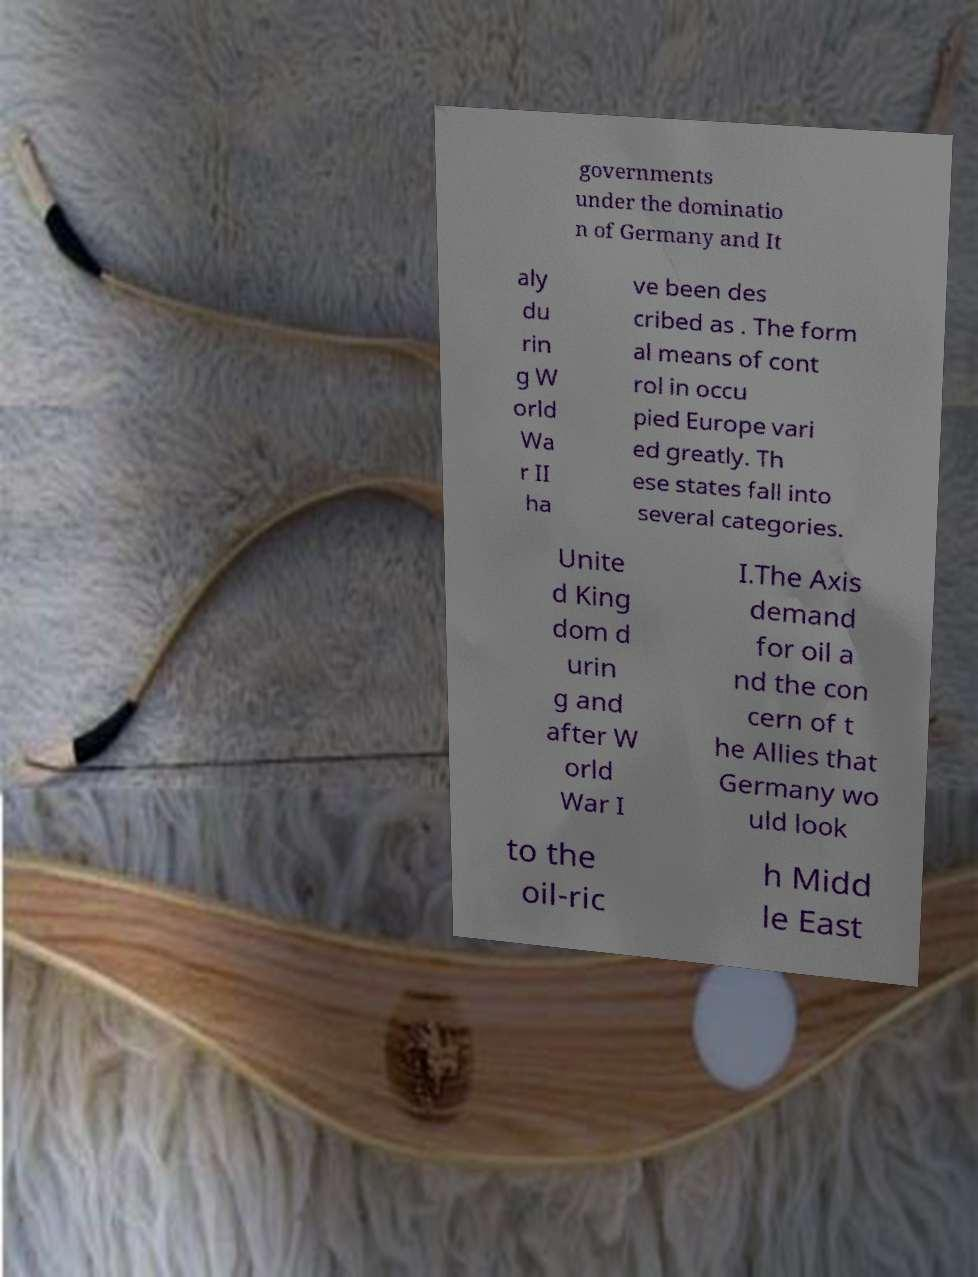Please read and relay the text visible in this image. What does it say? governments under the dominatio n of Germany and It aly du rin g W orld Wa r II ha ve been des cribed as . The form al means of cont rol in occu pied Europe vari ed greatly. Th ese states fall into several categories. Unite d King dom d urin g and after W orld War I I.The Axis demand for oil a nd the con cern of t he Allies that Germany wo uld look to the oil-ric h Midd le East 